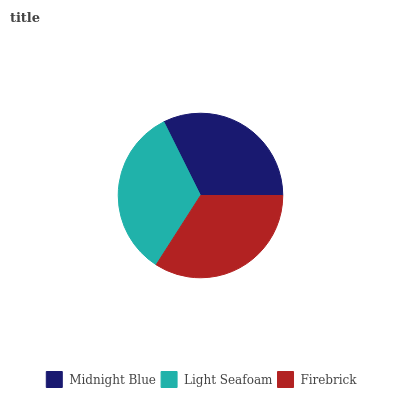Is Midnight Blue the minimum?
Answer yes or no. Yes. Is Firebrick the maximum?
Answer yes or no. Yes. Is Light Seafoam the minimum?
Answer yes or no. No. Is Light Seafoam the maximum?
Answer yes or no. No. Is Light Seafoam greater than Midnight Blue?
Answer yes or no. Yes. Is Midnight Blue less than Light Seafoam?
Answer yes or no. Yes. Is Midnight Blue greater than Light Seafoam?
Answer yes or no. No. Is Light Seafoam less than Midnight Blue?
Answer yes or no. No. Is Light Seafoam the high median?
Answer yes or no. Yes. Is Light Seafoam the low median?
Answer yes or no. Yes. Is Midnight Blue the high median?
Answer yes or no. No. Is Firebrick the low median?
Answer yes or no. No. 